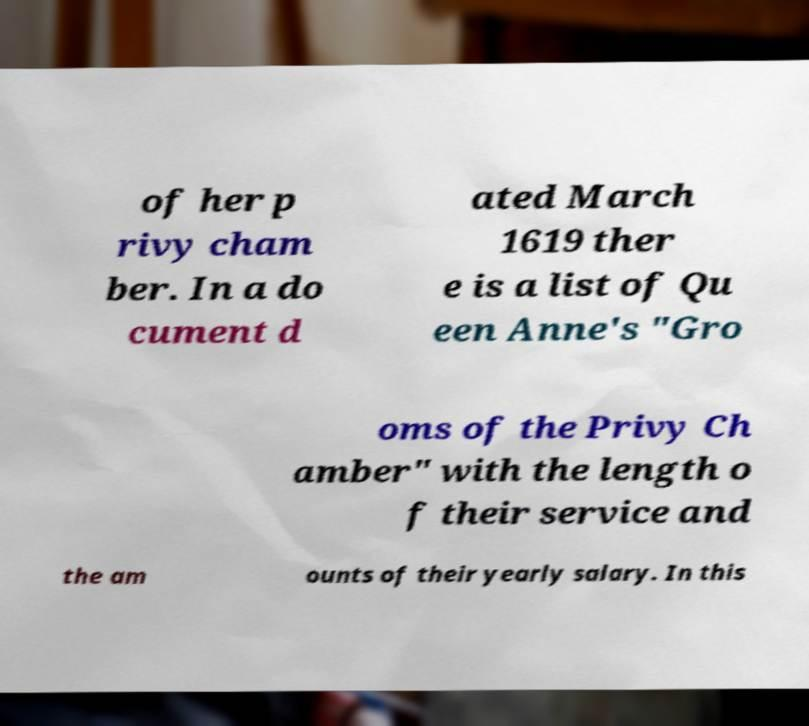Can you read and provide the text displayed in the image?This photo seems to have some interesting text. Can you extract and type it out for me? of her p rivy cham ber. In a do cument d ated March 1619 ther e is a list of Qu een Anne's "Gro oms of the Privy Ch amber" with the length o f their service and the am ounts of their yearly salary. In this 